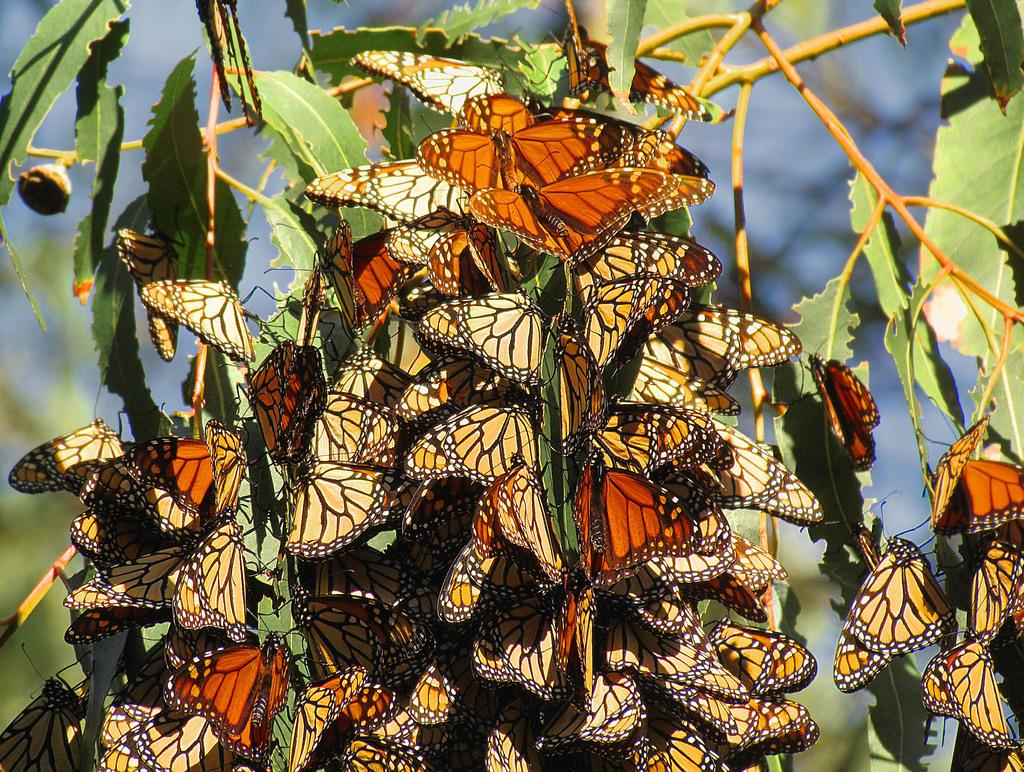What type of animals can be seen in the image? There are butterflies in the image. What other objects or elements can be seen in the image? There are leaves in the image. How would you describe the background of the image? The background of the image is blurry. What is the price of the belief system depicted in the image? There is no belief system or price mentioned in the image; it features butterflies and leaves with a blurry background. 